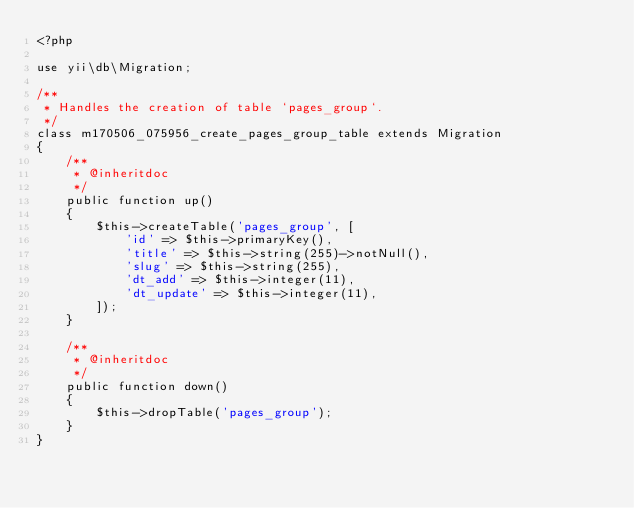Convert code to text. <code><loc_0><loc_0><loc_500><loc_500><_PHP_><?php

use yii\db\Migration;

/**
 * Handles the creation of table `pages_group`.
 */
class m170506_075956_create_pages_group_table extends Migration
{
    /**
     * @inheritdoc
     */
    public function up()
    {
        $this->createTable('pages_group', [
            'id' => $this->primaryKey(),
            'title' => $this->string(255)->notNull(),
            'slug' => $this->string(255),
            'dt_add' => $this->integer(11),
            'dt_update' => $this->integer(11),
        ]);
    }

    /**
     * @inheritdoc
     */
    public function down()
    {
        $this->dropTable('pages_group');
    }
}
</code> 